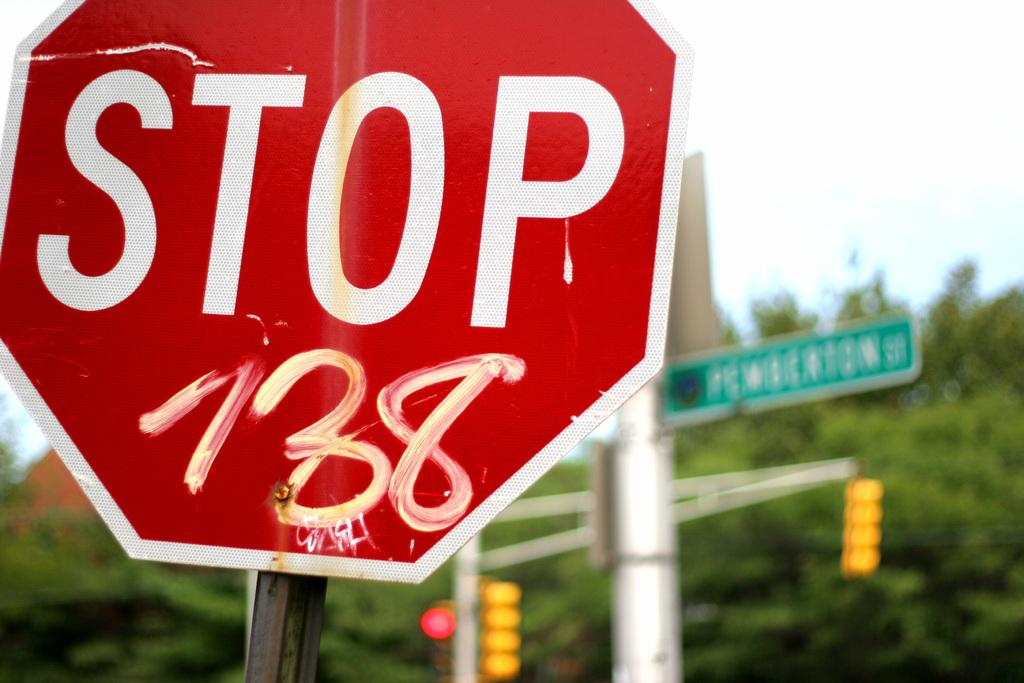<image>
Create a compact narrative representing the image presented. a stop sign that is outdoors and a green sign 